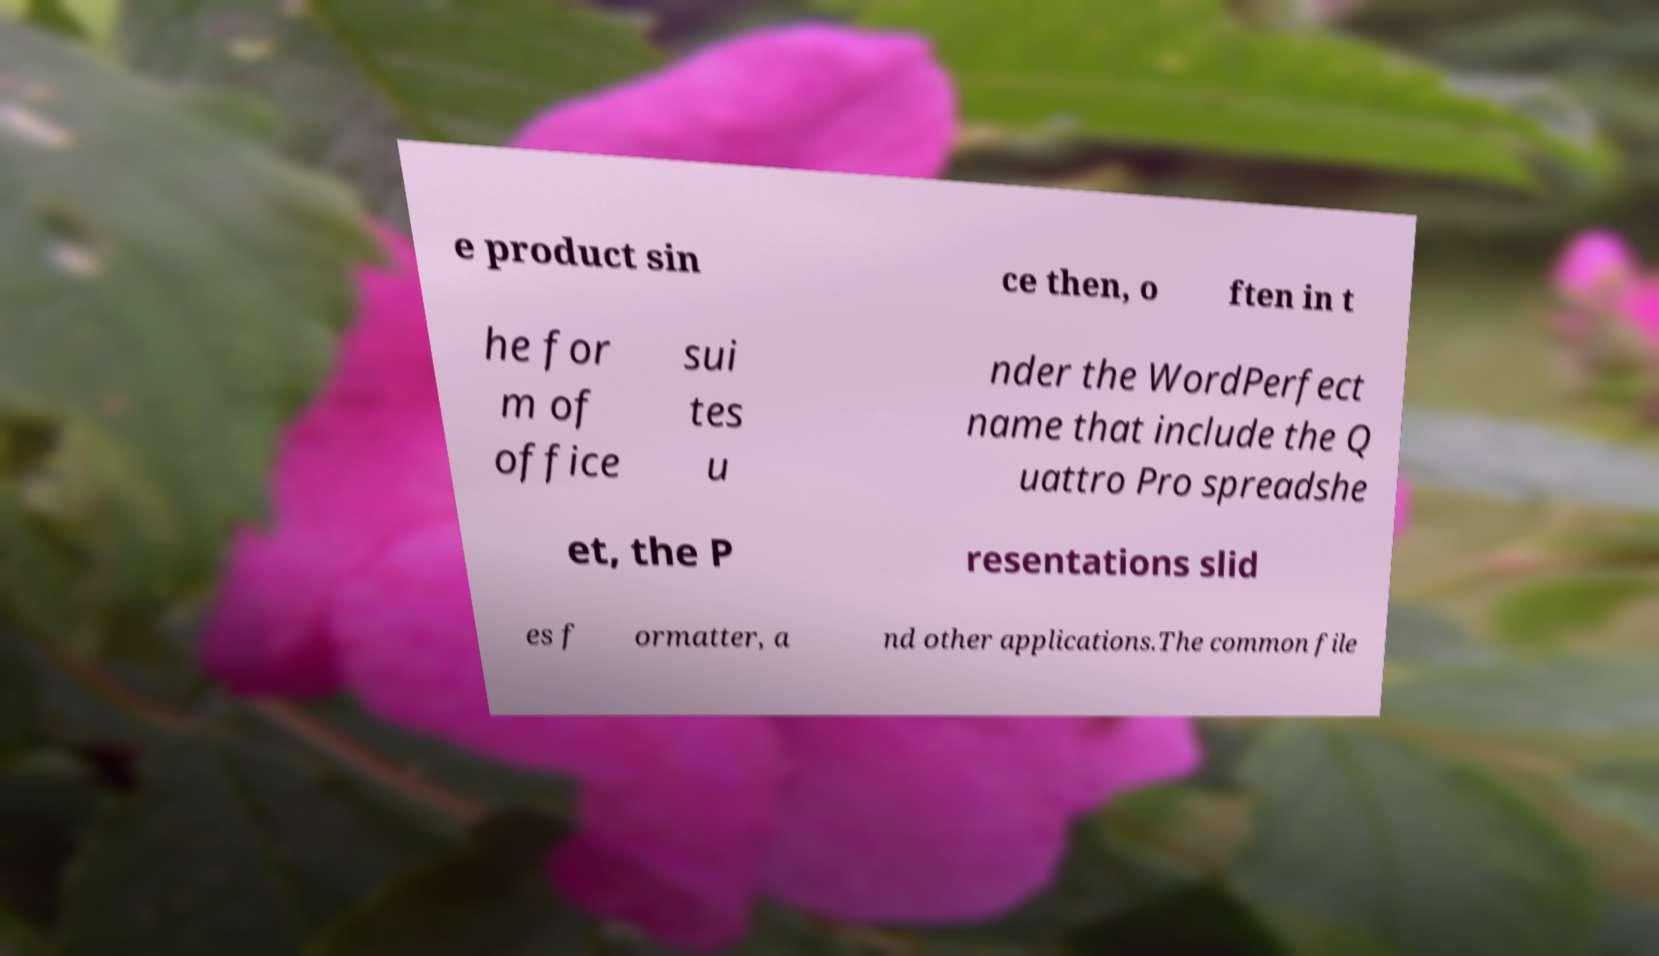Please read and relay the text visible in this image. What does it say? e product sin ce then, o ften in t he for m of office sui tes u nder the WordPerfect name that include the Q uattro Pro spreadshe et, the P resentations slid es f ormatter, a nd other applications.The common file 